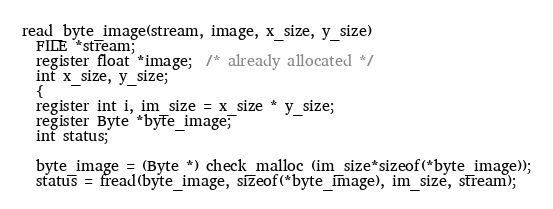<code> <loc_0><loc_0><loc_500><loc_500><_C_>read_byte_image(stream, image, x_size, y_size)
  FILE *stream;
  register float *image;  /* already allocated */
  int x_size, y_size;
  {
  register int i, im_size = x_size * y_size;
  register Byte *byte_image;
  int status;

  byte_image = (Byte *) check_malloc (im_size*sizeof(*byte_image));
  status = fread(byte_image, sizeof(*byte_image), im_size, stream);</code> 